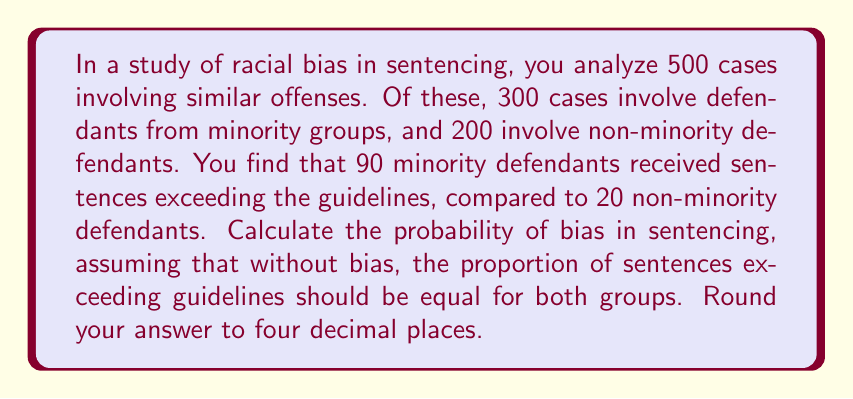Provide a solution to this math problem. Let's approach this step-by-step:

1) First, we need to calculate the overall rate of sentences exceeding guidelines:
   Total exceeding guidelines: $90 + 20 = 110$
   Total cases: $500$
   Overall rate: $\frac{110}{500} = 0.22$ or $22\%$

2) If there's no bias, we expect this rate to be the same for both groups. So:
   Expected number for minority group: $300 \times 0.22 = 66$
   Expected number for non-minority group: $200 \times 0.22 = 44$

3) We observe:
   Minority group: $90$
   Non-minority group: $20$

4) To test for bias, we can use a chi-square test. The formula is:
   $$\chi^2 = \sum \frac{(O - E)^2}{E}$$
   where $O$ is the observed value and $E$ is the expected value.

5) Calculating $\chi^2$:
   $$\chi^2 = \frac{(90 - 66)^2}{66} + \frac{(20 - 44)^2}{44} = \frac{576}{66} + \frac{576}{44} = 8.7273 + 13.0909 = 21.8182$$

6) For a 2x2 contingency table, we have 1 degree of freedom.

7) To find the probability of bias, we need to calculate $P(\chi^2 > 21.8182)$ with 1 degree of freedom.

8) Using a chi-square distribution table or calculator, we find:
   $P(\chi^2 > 21.8182) \approx 0.0000$

This extremely low p-value suggests strong evidence of bias in sentencing.
Answer: $\approx 0.9999$ 